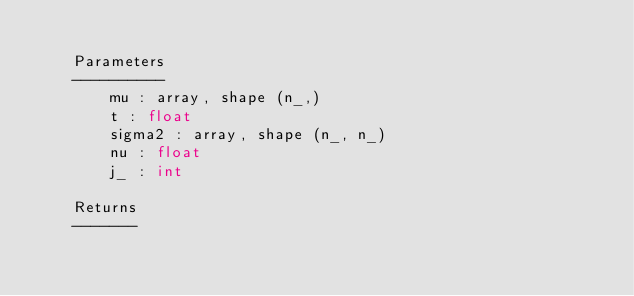<code> <loc_0><loc_0><loc_500><loc_500><_Python_>
    Parameters
    ----------
        mu : array, shape (n_,)
        t : float
        sigma2 : array, shape (n_, n_)
        nu : float
        j_ : int

    Returns
    -------</code> 